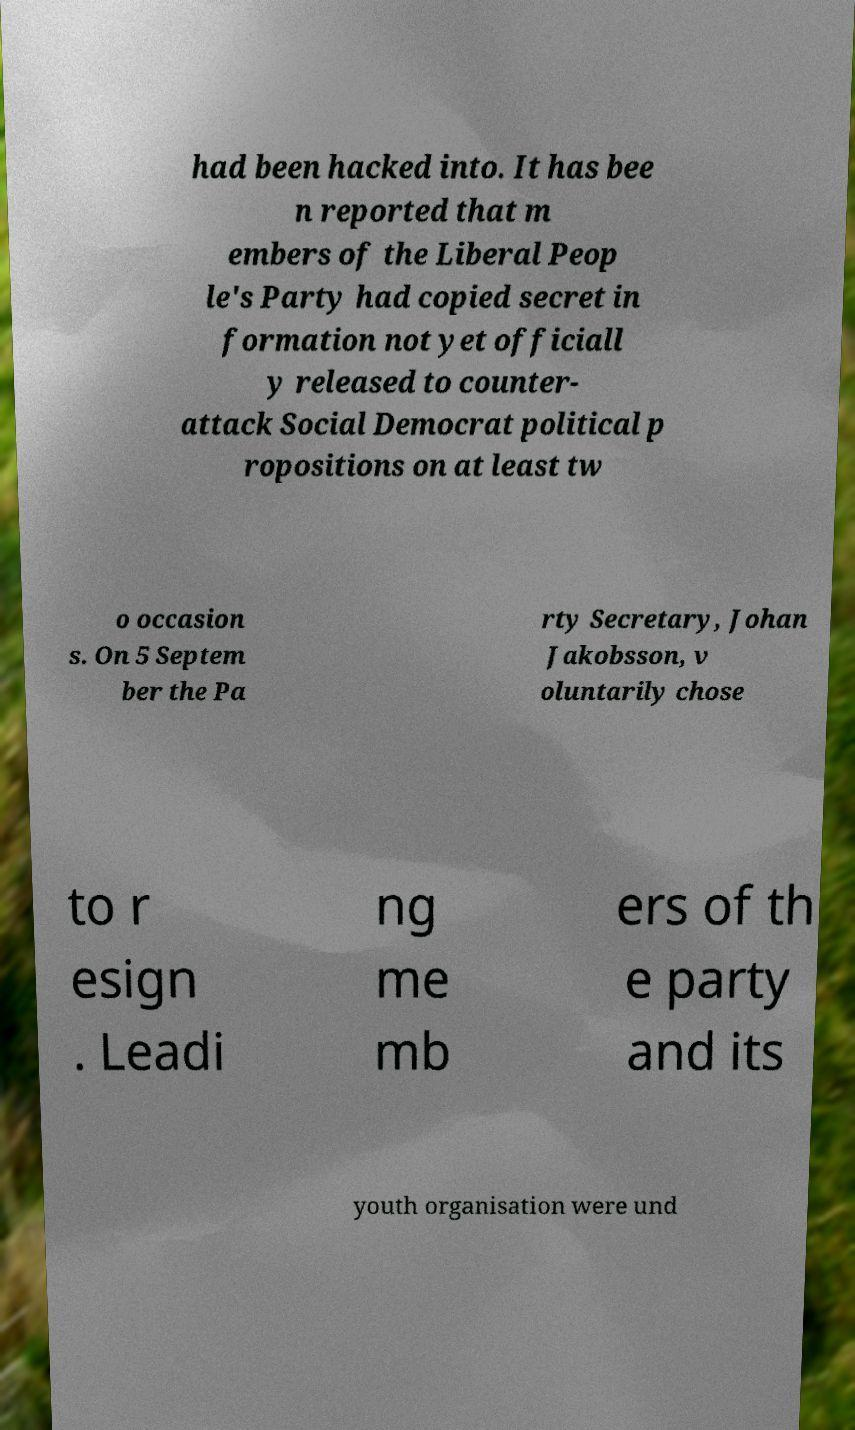For documentation purposes, I need the text within this image transcribed. Could you provide that? had been hacked into. It has bee n reported that m embers of the Liberal Peop le's Party had copied secret in formation not yet officiall y released to counter- attack Social Democrat political p ropositions on at least tw o occasion s. On 5 Septem ber the Pa rty Secretary, Johan Jakobsson, v oluntarily chose to r esign . Leadi ng me mb ers of th e party and its youth organisation were und 